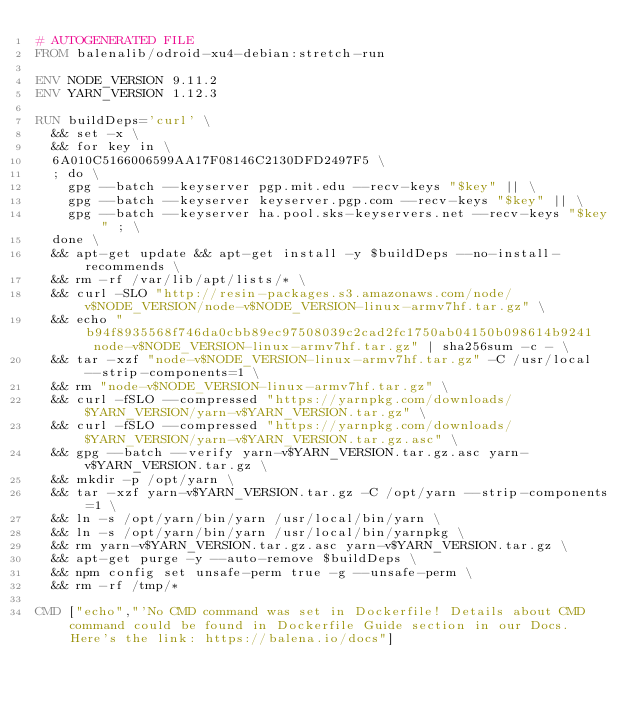Convert code to text. <code><loc_0><loc_0><loc_500><loc_500><_Dockerfile_># AUTOGENERATED FILE
FROM balenalib/odroid-xu4-debian:stretch-run

ENV NODE_VERSION 9.11.2
ENV YARN_VERSION 1.12.3

RUN buildDeps='curl' \
	&& set -x \
	&& for key in \
	6A010C5166006599AA17F08146C2130DFD2497F5 \
	; do \
		gpg --batch --keyserver pgp.mit.edu --recv-keys "$key" || \
		gpg --batch --keyserver keyserver.pgp.com --recv-keys "$key" || \
		gpg --batch --keyserver ha.pool.sks-keyservers.net --recv-keys "$key" ; \
	done \
	&& apt-get update && apt-get install -y $buildDeps --no-install-recommends \
	&& rm -rf /var/lib/apt/lists/* \
	&& curl -SLO "http://resin-packages.s3.amazonaws.com/node/v$NODE_VERSION/node-v$NODE_VERSION-linux-armv7hf.tar.gz" \
	&& echo "b94f8935568f746da0cbb89ec97508039c2cad2fc1750ab04150b098614b9241  node-v$NODE_VERSION-linux-armv7hf.tar.gz" | sha256sum -c - \
	&& tar -xzf "node-v$NODE_VERSION-linux-armv7hf.tar.gz" -C /usr/local --strip-components=1 \
	&& rm "node-v$NODE_VERSION-linux-armv7hf.tar.gz" \
	&& curl -fSLO --compressed "https://yarnpkg.com/downloads/$YARN_VERSION/yarn-v$YARN_VERSION.tar.gz" \
	&& curl -fSLO --compressed "https://yarnpkg.com/downloads/$YARN_VERSION/yarn-v$YARN_VERSION.tar.gz.asc" \
	&& gpg --batch --verify yarn-v$YARN_VERSION.tar.gz.asc yarn-v$YARN_VERSION.tar.gz \
	&& mkdir -p /opt/yarn \
	&& tar -xzf yarn-v$YARN_VERSION.tar.gz -C /opt/yarn --strip-components=1 \
	&& ln -s /opt/yarn/bin/yarn /usr/local/bin/yarn \
	&& ln -s /opt/yarn/bin/yarn /usr/local/bin/yarnpkg \
	&& rm yarn-v$YARN_VERSION.tar.gz.asc yarn-v$YARN_VERSION.tar.gz \
	&& apt-get purge -y --auto-remove $buildDeps \
	&& npm config set unsafe-perm true -g --unsafe-perm \
	&& rm -rf /tmp/*

CMD ["echo","'No CMD command was set in Dockerfile! Details about CMD command could be found in Dockerfile Guide section in our Docs. Here's the link: https://balena.io/docs"]</code> 